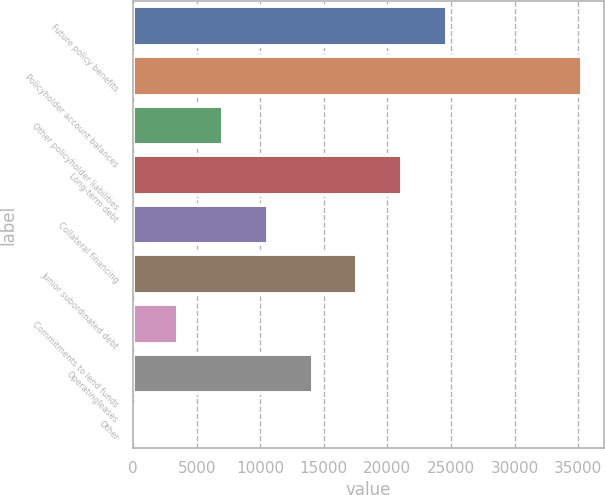Convert chart to OTSL. <chart><loc_0><loc_0><loc_500><loc_500><bar_chart><fcel>Future policy benefits<fcel>Policyholder account balances<fcel>Other policyholder liabilities<fcel>Long-term debt<fcel>Collateral financing<fcel>Junior subordinated debt<fcel>Commitments to lend funds<fcel>Operatingleases<fcel>Other<nl><fcel>24696.9<fcel>35280<fcel>7058.4<fcel>21169.2<fcel>10586.1<fcel>17641.5<fcel>3530.7<fcel>14113.8<fcel>3<nl></chart> 